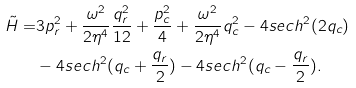<formula> <loc_0><loc_0><loc_500><loc_500>\tilde { H } = & 3 p _ { r } ^ { 2 } + \frac { \omega ^ { 2 } } { 2 \eta ^ { 4 } } \frac { q _ { r } ^ { 2 } } { 1 2 } + \frac { p _ { c } ^ { 2 } } { 4 } + \frac { \omega ^ { 2 } } { 2 \eta ^ { 4 } } q _ { c } ^ { 2 } - 4 s e c h ^ { 2 } ( 2 q _ { c } ) \\ & - 4 s e c h ^ { 2 } ( q _ { c } + \frac { q _ { r } } { 2 } ) - 4 s e c h ^ { 2 } ( q _ { c } - \frac { q _ { r } } { 2 } ) .</formula> 